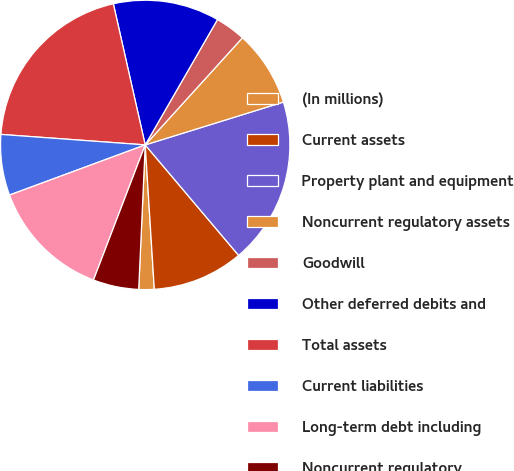Convert chart. <chart><loc_0><loc_0><loc_500><loc_500><pie_chart><fcel>(In millions)<fcel>Current assets<fcel>Property plant and equipment<fcel>Noncurrent regulatory assets<fcel>Goodwill<fcel>Other deferred debits and<fcel>Total assets<fcel>Current liabilities<fcel>Long-term debt including<fcel>Noncurrent regulatory<nl><fcel>1.72%<fcel>10.17%<fcel>18.62%<fcel>8.48%<fcel>3.41%<fcel>11.86%<fcel>20.31%<fcel>6.79%<fcel>13.55%<fcel>5.1%<nl></chart> 